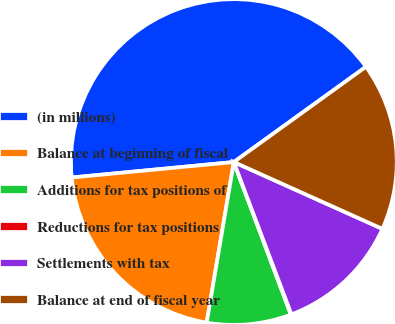<chart> <loc_0><loc_0><loc_500><loc_500><pie_chart><fcel>(in millions)<fcel>Balance at beginning of fiscal<fcel>Additions for tax positions of<fcel>Reductions for tax positions<fcel>Settlements with tax<fcel>Balance at end of fiscal year<nl><fcel>41.57%<fcel>20.82%<fcel>8.36%<fcel>0.06%<fcel>12.52%<fcel>16.67%<nl></chart> 